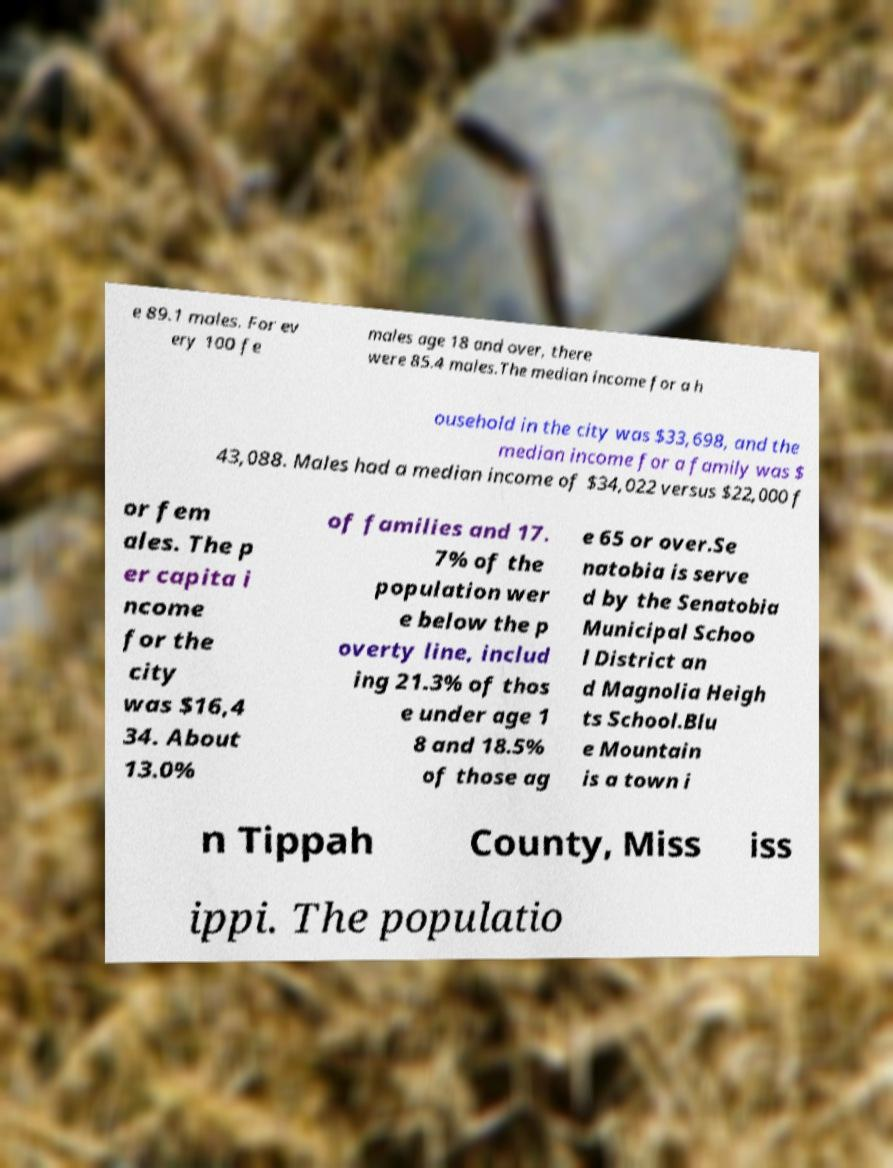I need the written content from this picture converted into text. Can you do that? e 89.1 males. For ev ery 100 fe males age 18 and over, there were 85.4 males.The median income for a h ousehold in the city was $33,698, and the median income for a family was $ 43,088. Males had a median income of $34,022 versus $22,000 f or fem ales. The p er capita i ncome for the city was $16,4 34. About 13.0% of families and 17. 7% of the population wer e below the p overty line, includ ing 21.3% of thos e under age 1 8 and 18.5% of those ag e 65 or over.Se natobia is serve d by the Senatobia Municipal Schoo l District an d Magnolia Heigh ts School.Blu e Mountain is a town i n Tippah County, Miss iss ippi. The populatio 